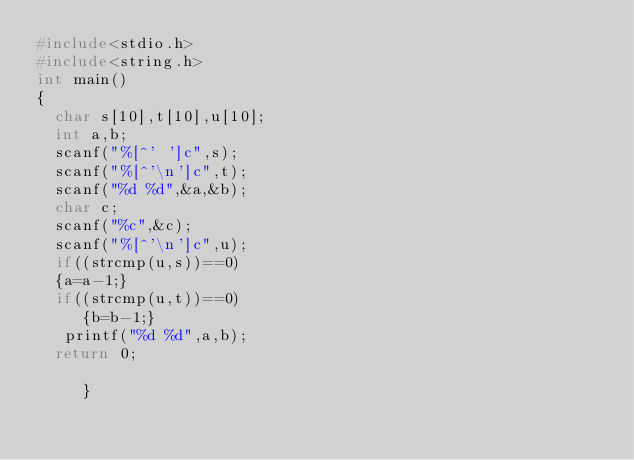Convert code to text. <code><loc_0><loc_0><loc_500><loc_500><_C_>#include<stdio.h>
#include<string.h>
int main()
{
  char s[10],t[10],u[10];
  int a,b;
  scanf("%[^' ']c",s);
  scanf("%[^'\n']c",t);
  scanf("%d %d",&a,&b);
  char c;
  scanf("%c",&c);
  scanf("%[^'\n']c",u);
  if((strcmp(u,s))==0)
  {a=a-1;}
  if((strcmp(u,t))==0)
     {b=b-1;}
   printf("%d %d",a,b);
  return 0;
     
     }
     
</code> 